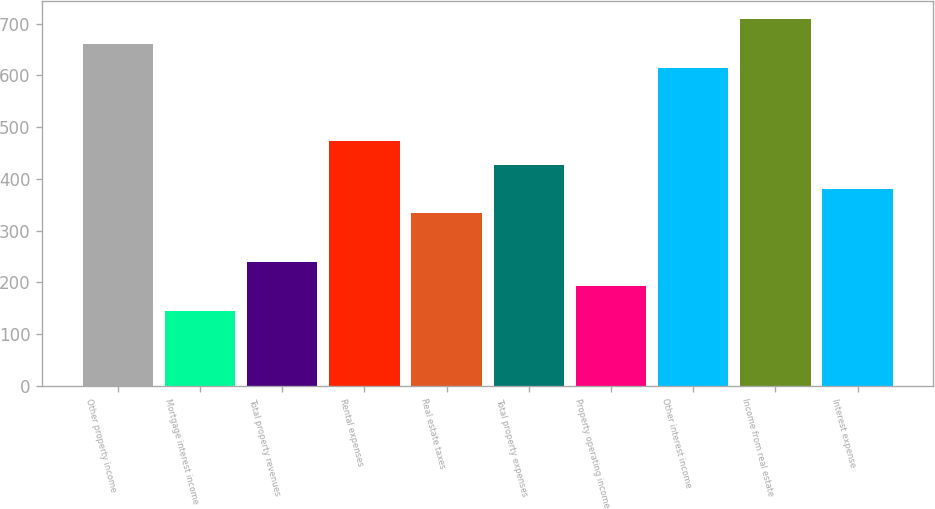Convert chart. <chart><loc_0><loc_0><loc_500><loc_500><bar_chart><fcel>Other property income<fcel>Mortgage interest income<fcel>Total property revenues<fcel>Rental expenses<fcel>Real estate taxes<fcel>Total property expenses<fcel>Property operating income<fcel>Other interest income<fcel>Income from real estate<fcel>Interest expense<nl><fcel>661.56<fcel>145.22<fcel>239.1<fcel>473.8<fcel>332.98<fcel>426.86<fcel>192.16<fcel>614.62<fcel>708.5<fcel>379.92<nl></chart> 